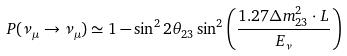<formula> <loc_0><loc_0><loc_500><loc_500>P ( \nu _ { \mu } \rightarrow \nu _ { \mu } ) \simeq 1 - \sin ^ { 2 } 2 \theta _ { 2 3 } \sin ^ { 2 } \left ( \frac { 1 . 2 7 \Delta m ^ { 2 } _ { 2 3 } \cdot L } { E _ { \nu } } \right )</formula> 